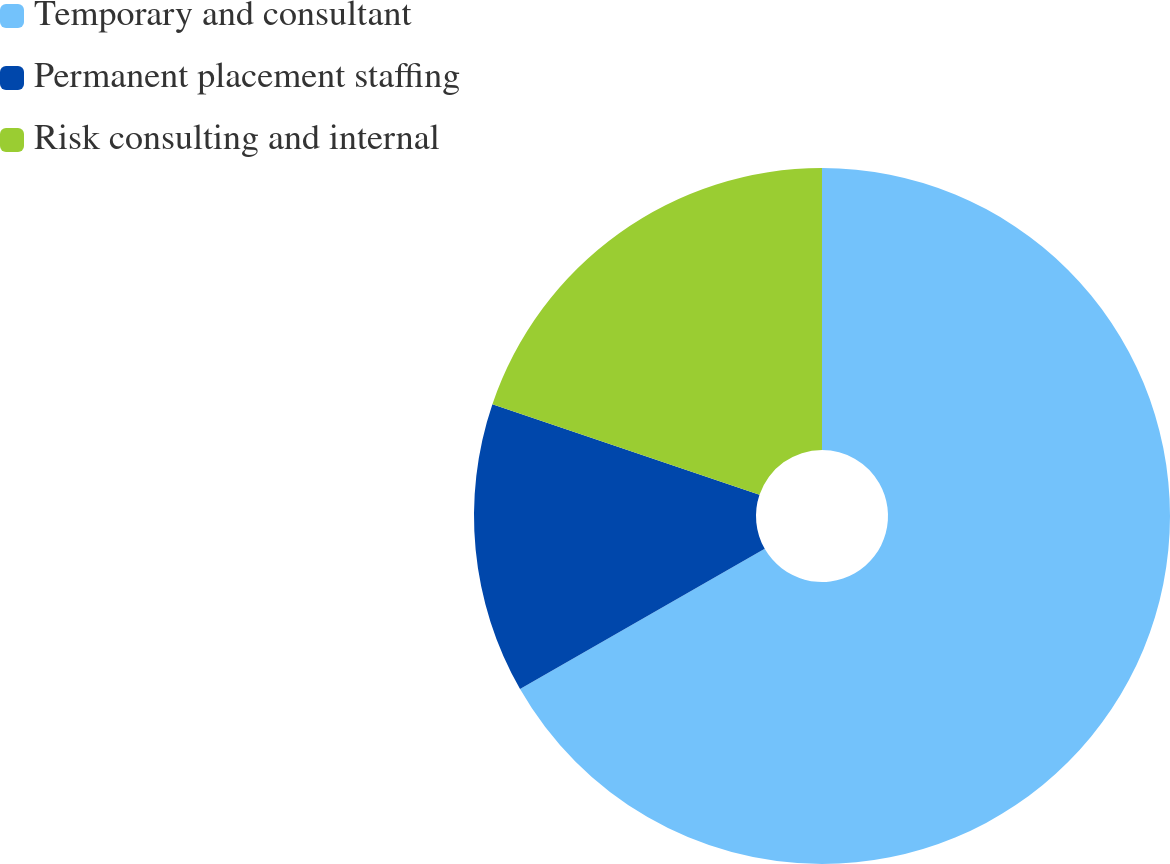<chart> <loc_0><loc_0><loc_500><loc_500><pie_chart><fcel>Temporary and consultant<fcel>Permanent placement staffing<fcel>Risk consulting and internal<nl><fcel>66.72%<fcel>13.48%<fcel>19.8%<nl></chart> 